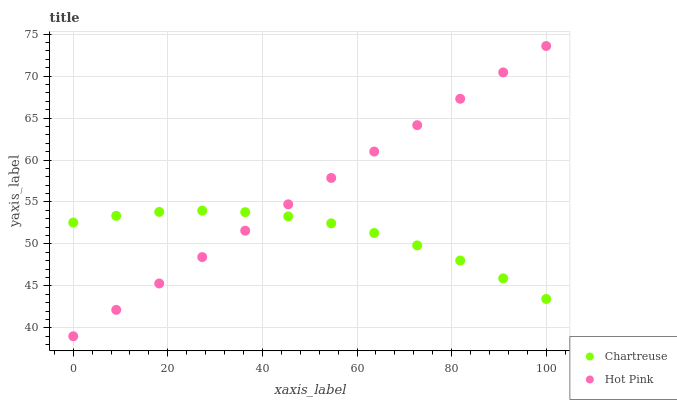Does Chartreuse have the minimum area under the curve?
Answer yes or no. Yes. Does Hot Pink have the maximum area under the curve?
Answer yes or no. Yes. Does Hot Pink have the minimum area under the curve?
Answer yes or no. No. Is Hot Pink the smoothest?
Answer yes or no. Yes. Is Chartreuse the roughest?
Answer yes or no. Yes. Is Hot Pink the roughest?
Answer yes or no. No. Does Hot Pink have the lowest value?
Answer yes or no. Yes. Does Hot Pink have the highest value?
Answer yes or no. Yes. Does Hot Pink intersect Chartreuse?
Answer yes or no. Yes. Is Hot Pink less than Chartreuse?
Answer yes or no. No. Is Hot Pink greater than Chartreuse?
Answer yes or no. No. 